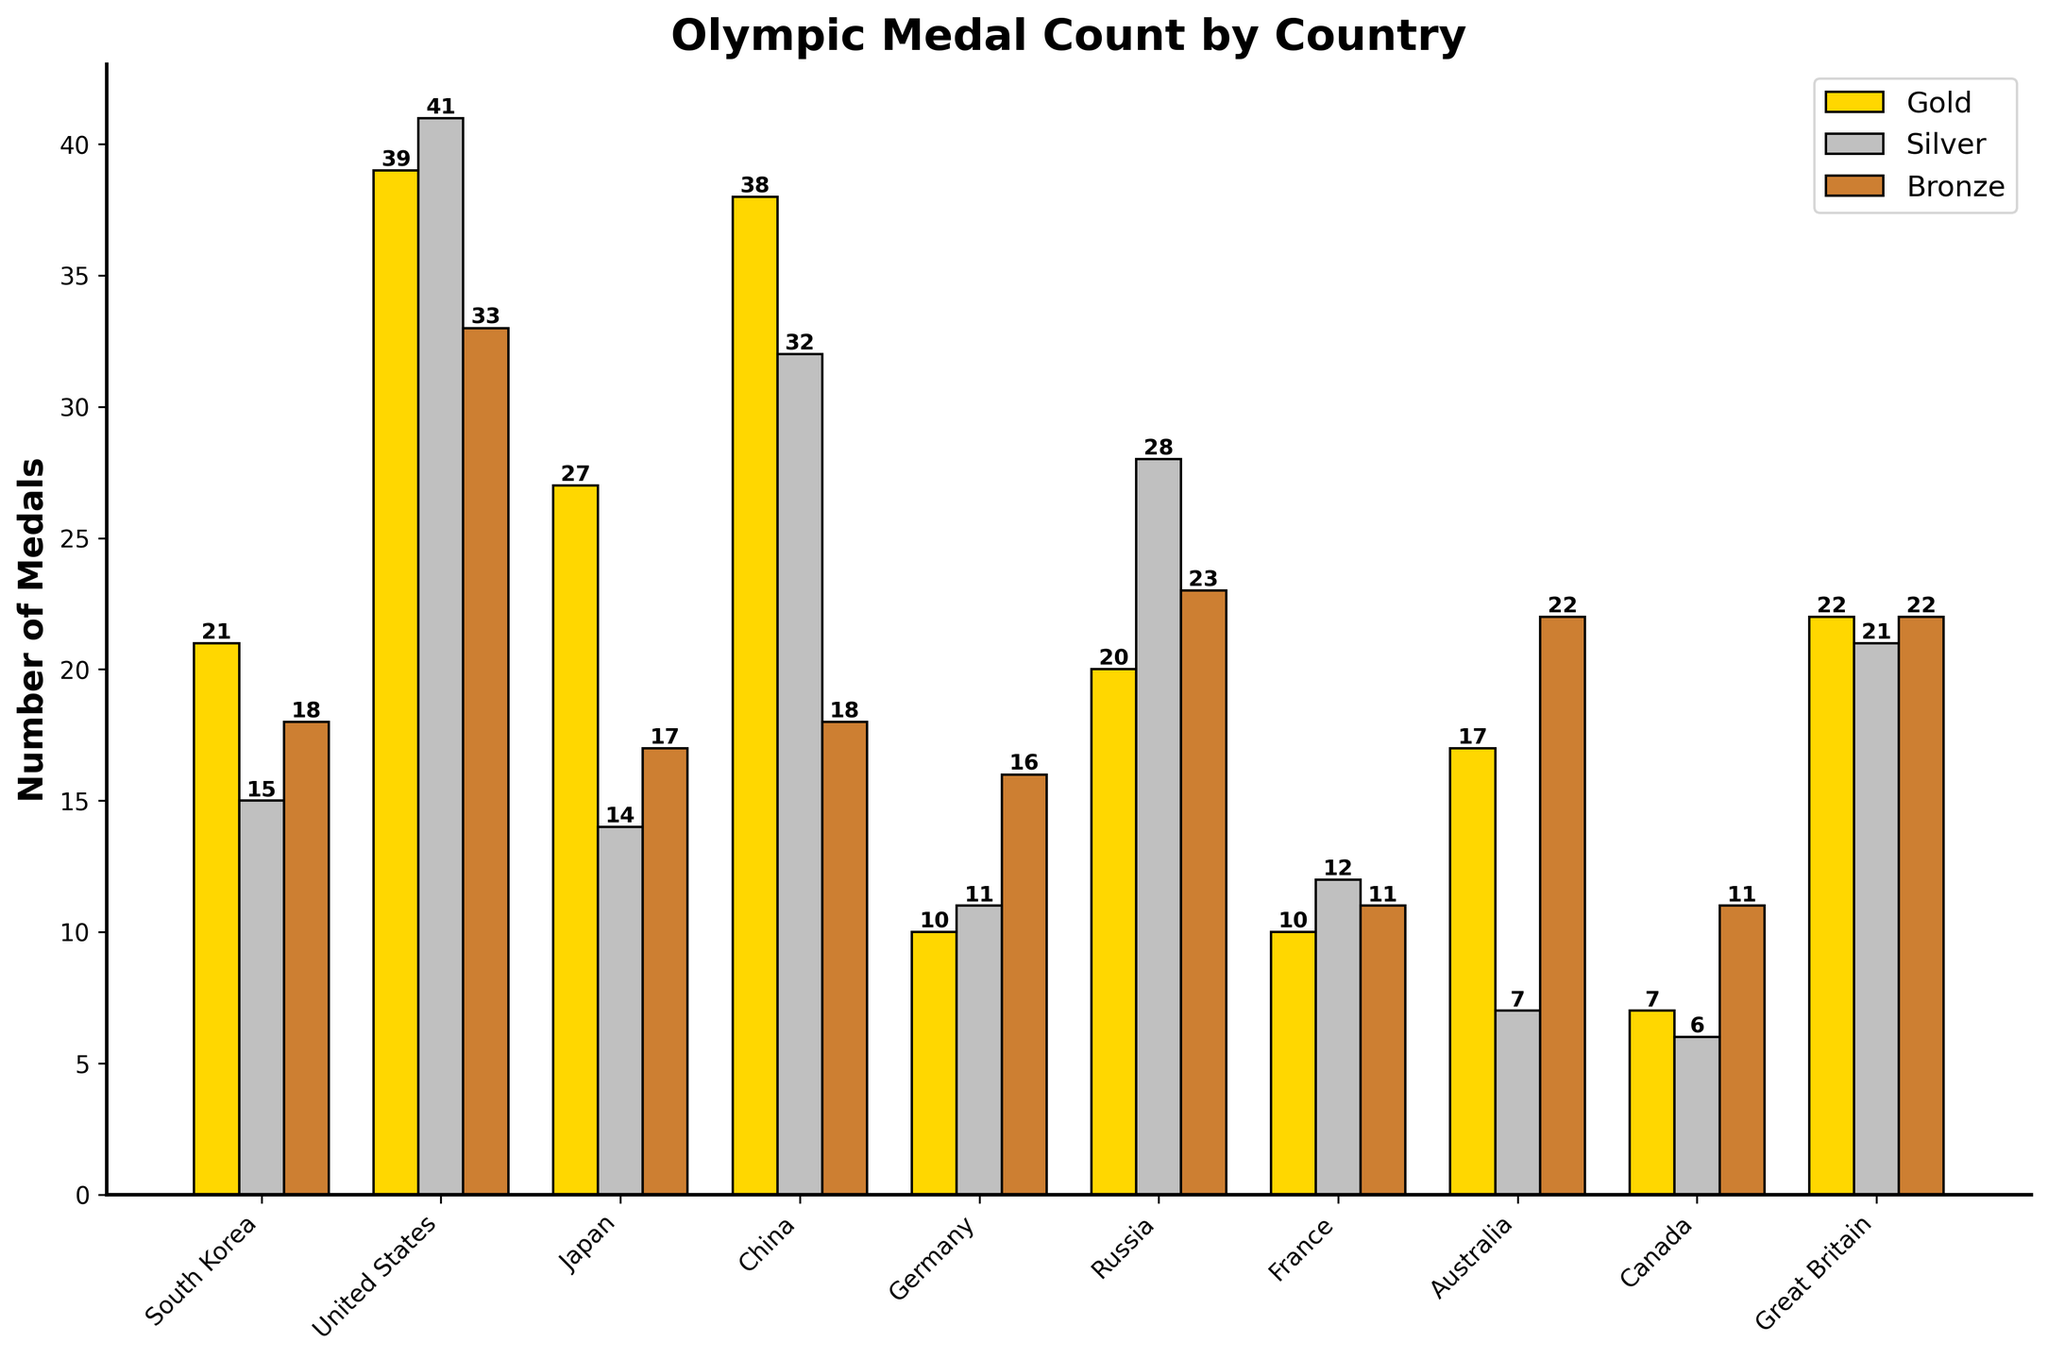Which country has the highest total number of medals? The country with the highest total number of medals is the one with the tallest bar in the "Total" category. Looking at the chart, the United States has the tallest bar.
Answer: United States How many gold medals did South Korea win compared to Japan? To determine the difference in gold medals between South Korea and Japan, subtract the number of gold medals Japan won from the number South Korea won. South Korea has 21 gold medals, and Japan has 27 gold medals. \(27 - 21 = 6\).
Answer: 6 Which country won more silver medals, China or Russia? Compare the height of the silver medal bars for China and Russia. China has 32 silver medals, while Russia has 28 silver medals.
Answer: China What is the total number of bronze medals won by Germany and Great Britain combined? Sum the number of bronze medals won by Germany and Great Britain. Germany has 16 bronze medals and Great Britain has 22 bronze medals. \(16 + 22 = 38\).
Answer: 38 Which country has the smallest number of total medals? The country with the shortest bar in the "Total" category has the smallest number of total medals. Canada has the shortest bar with 24 medals.
Answer: Canada How many more total medals did the United States win compared to South Korea? Subtract the total number of medals South Korea won from the total number of medals the United States won. The United States has 113 total medals, and South Korea has 54 total medals. \(113 - 54 = 59\).
Answer: 59 Which country has more bronze medals, Australia or South Korea? Compare the height of the bronze medal bars for Australia and South Korea. Australia has 22 bronze medals, while South Korea has 18 bronze medals.
Answer: Australia What is the average number of gold medals won by the listed countries? Sum the number of gold medals won by each country and divide it by the number of countries. \(21 + 39 + 27 + 38 + 10 + 20 + 10 + 17 + 7 + 22 = 211\). There are 10 countries, so \(211 / 10 = 21.1\).
Answer: 21.1 Did France win more than or less than 10 silver medals? Look at the height of the silver medal bar for France. France won 12 silver medals, which is more than 10.
Answer: More than 10 Which country has fewer gold medals, Germany or Russia? Compare the heights of the gold medal bars for Germany and Russia. Germany has 10 gold medals, while Russia has 20 gold medals.
Answer: Germany 